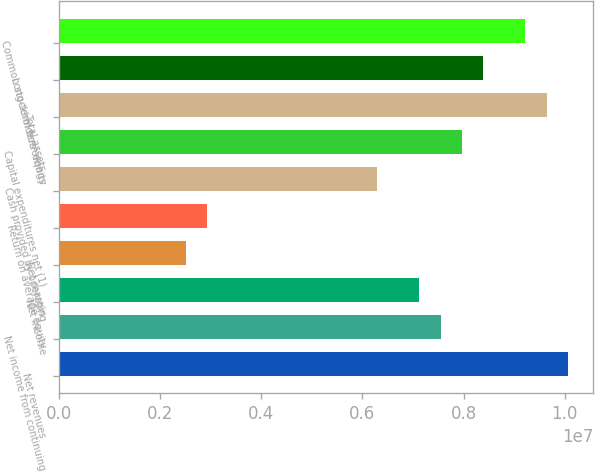Convert chart to OTSL. <chart><loc_0><loc_0><loc_500><loc_500><bar_chart><fcel>Net revenues<fcel>Net income from continuing<fcel>Net income<fcel>Net margin<fcel>Return on average equity<fcel>Cash provided by operating<fcel>Capital expenditures net (1)<fcel>Total assets<fcel>Long-term borrowings<fcel>Common stockholders' equity<nl><fcel>1.00591e+07<fcel>7.54434e+06<fcel>7.12521e+06<fcel>2.51478e+06<fcel>2.93391e+06<fcel>6.28695e+06<fcel>7.96347e+06<fcel>9.63999e+06<fcel>8.3826e+06<fcel>9.22086e+06<nl></chart> 